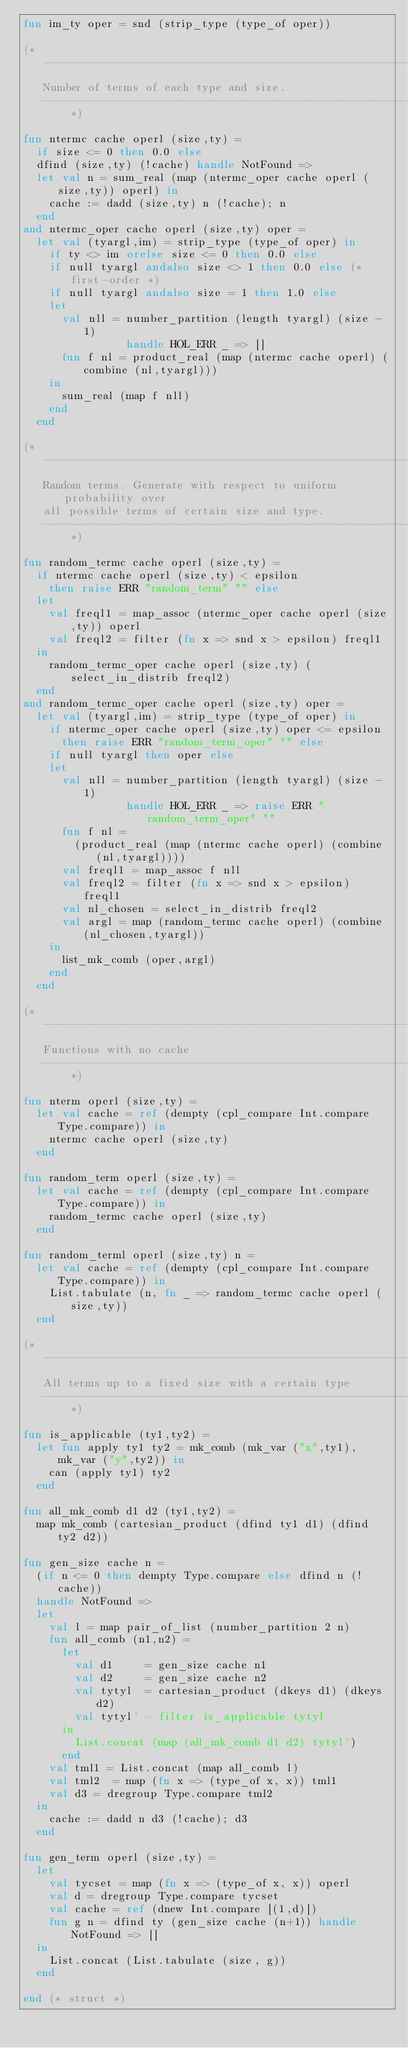<code> <loc_0><loc_0><loc_500><loc_500><_SML_>fun im_ty oper = snd (strip_type (type_of oper))

(* -------------------------------------------------------------------------
   Number of terms of each type and size.
   ------------------------------------------------------------------------- *)

fun ntermc cache operl (size,ty) =
  if size <= 0 then 0.0 else
  dfind (size,ty) (!cache) handle NotFound =>
  let val n = sum_real (map (ntermc_oper cache operl (size,ty)) operl) in
    cache := dadd (size,ty) n (!cache); n
  end
and ntermc_oper cache operl (size,ty) oper =
  let val (tyargl,im) = strip_type (type_of oper) in
    if ty <> im orelse size <= 0 then 0.0 else
    if null tyargl andalso size <> 1 then 0.0 else (* first-order *)
    if null tyargl andalso size = 1 then 1.0 else
    let
      val nll = number_partition (length tyargl) (size - 1)
                handle HOL_ERR _ => []
      fun f nl = product_real (map (ntermc cache operl) (combine (nl,tyargl)))
    in
      sum_real (map f nll)
    end
  end

(* -------------------------------------------------------------------------
   Random terms. Generate with respect to uniform probability over
   all possible terms of certain size and type.
   ------------------------------------------------------------------------- *)

fun random_termc cache operl (size,ty) =
  if ntermc cache operl (size,ty) < epsilon
    then raise ERR "random_term" "" else
  let
    val freql1 = map_assoc (ntermc_oper cache operl (size,ty)) operl
    val freql2 = filter (fn x => snd x > epsilon) freql1
  in
    random_termc_oper cache operl (size,ty) (select_in_distrib freql2)
  end
and random_termc_oper cache operl (size,ty) oper =
  let val (tyargl,im) = strip_type (type_of oper) in
    if ntermc_oper cache operl (size,ty) oper <= epsilon
      then raise ERR "random_term_oper" "" else
    if null tyargl then oper else
    let
      val nll = number_partition (length tyargl) (size - 1)
                handle HOL_ERR _ => raise ERR "random_term_oper" ""
      fun f nl =
        (product_real (map (ntermc cache operl) (combine (nl,tyargl))))
      val freql1 = map_assoc f nll
      val freql2 = filter (fn x => snd x > epsilon) freql1
      val nl_chosen = select_in_distrib freql2
      val argl = map (random_termc cache operl) (combine (nl_chosen,tyargl))
    in
      list_mk_comb (oper,argl)
    end
  end

(* -------------------------------------------------------------------------
   Functions with no cache
   ------------------------------------------------------------------------- *)

fun nterm operl (size,ty) =
  let val cache = ref (dempty (cpl_compare Int.compare Type.compare)) in
    ntermc cache operl (size,ty)
  end

fun random_term operl (size,ty) =
  let val cache = ref (dempty (cpl_compare Int.compare Type.compare)) in
    random_termc cache operl (size,ty)
  end

fun random_terml operl (size,ty) n =
  let val cache = ref (dempty (cpl_compare Int.compare Type.compare)) in
    List.tabulate (n, fn _ => random_termc cache operl (size,ty))
  end

(* -------------------------------------------------------------------------
   All terms up to a fixed size with a certain type
   ------------------------------------------------------------------------- *)

fun is_applicable (ty1,ty2) =
  let fun apply ty1 ty2 = mk_comb (mk_var ("x",ty1), mk_var ("y",ty2)) in
    can (apply ty1) ty2
  end

fun all_mk_comb d1 d2 (ty1,ty2) =
  map mk_comb (cartesian_product (dfind ty1 d1) (dfind ty2 d2))

fun gen_size cache n =
  (if n <= 0 then dempty Type.compare else dfind n (!cache))
  handle NotFound =>
  let
    val l = map pair_of_list (number_partition 2 n)
    fun all_comb (n1,n2) =
      let
        val d1     = gen_size cache n1
        val d2     = gen_size cache n2
        val tytyl  = cartesian_product (dkeys d1) (dkeys d2)
        val tytyl' = filter is_applicable tytyl
      in
        List.concat (map (all_mk_comb d1 d2) tytyl')
      end
    val tml1 = List.concat (map all_comb l)
    val tml2  = map (fn x => (type_of x, x)) tml1
    val d3 = dregroup Type.compare tml2
  in
    cache := dadd n d3 (!cache); d3
  end

fun gen_term operl (size,ty) =
  let
    val tycset = map (fn x => (type_of x, x)) operl
    val d = dregroup Type.compare tycset
    val cache = ref (dnew Int.compare [(1,d)])
    fun g n = dfind ty (gen_size cache (n+1)) handle NotFound => []
  in
    List.concat (List.tabulate (size, g))
  end

end (* struct *)
</code> 